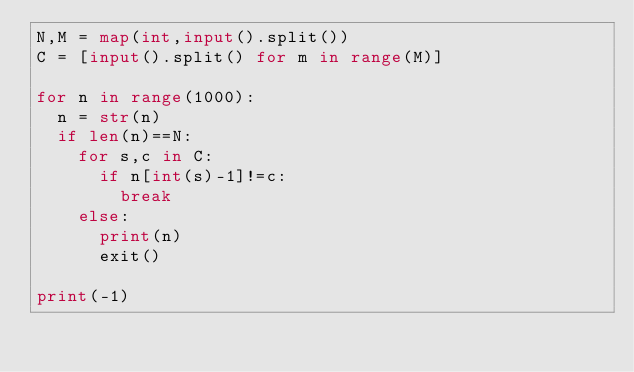Convert code to text. <code><loc_0><loc_0><loc_500><loc_500><_Python_>N,M = map(int,input().split())
C = [input().split() for m in range(M)]

for n in range(1000):
  n = str(n)
  if len(n)==N:
    for s,c in C:
      if n[int(s)-1]!=c:
        break
    else:
      print(n)
      exit()

print(-1)</code> 